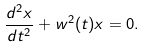Convert formula to latex. <formula><loc_0><loc_0><loc_500><loc_500>\frac { d ^ { 2 } x } { d t ^ { 2 } } + w ^ { 2 } ( t ) x = 0 .</formula> 